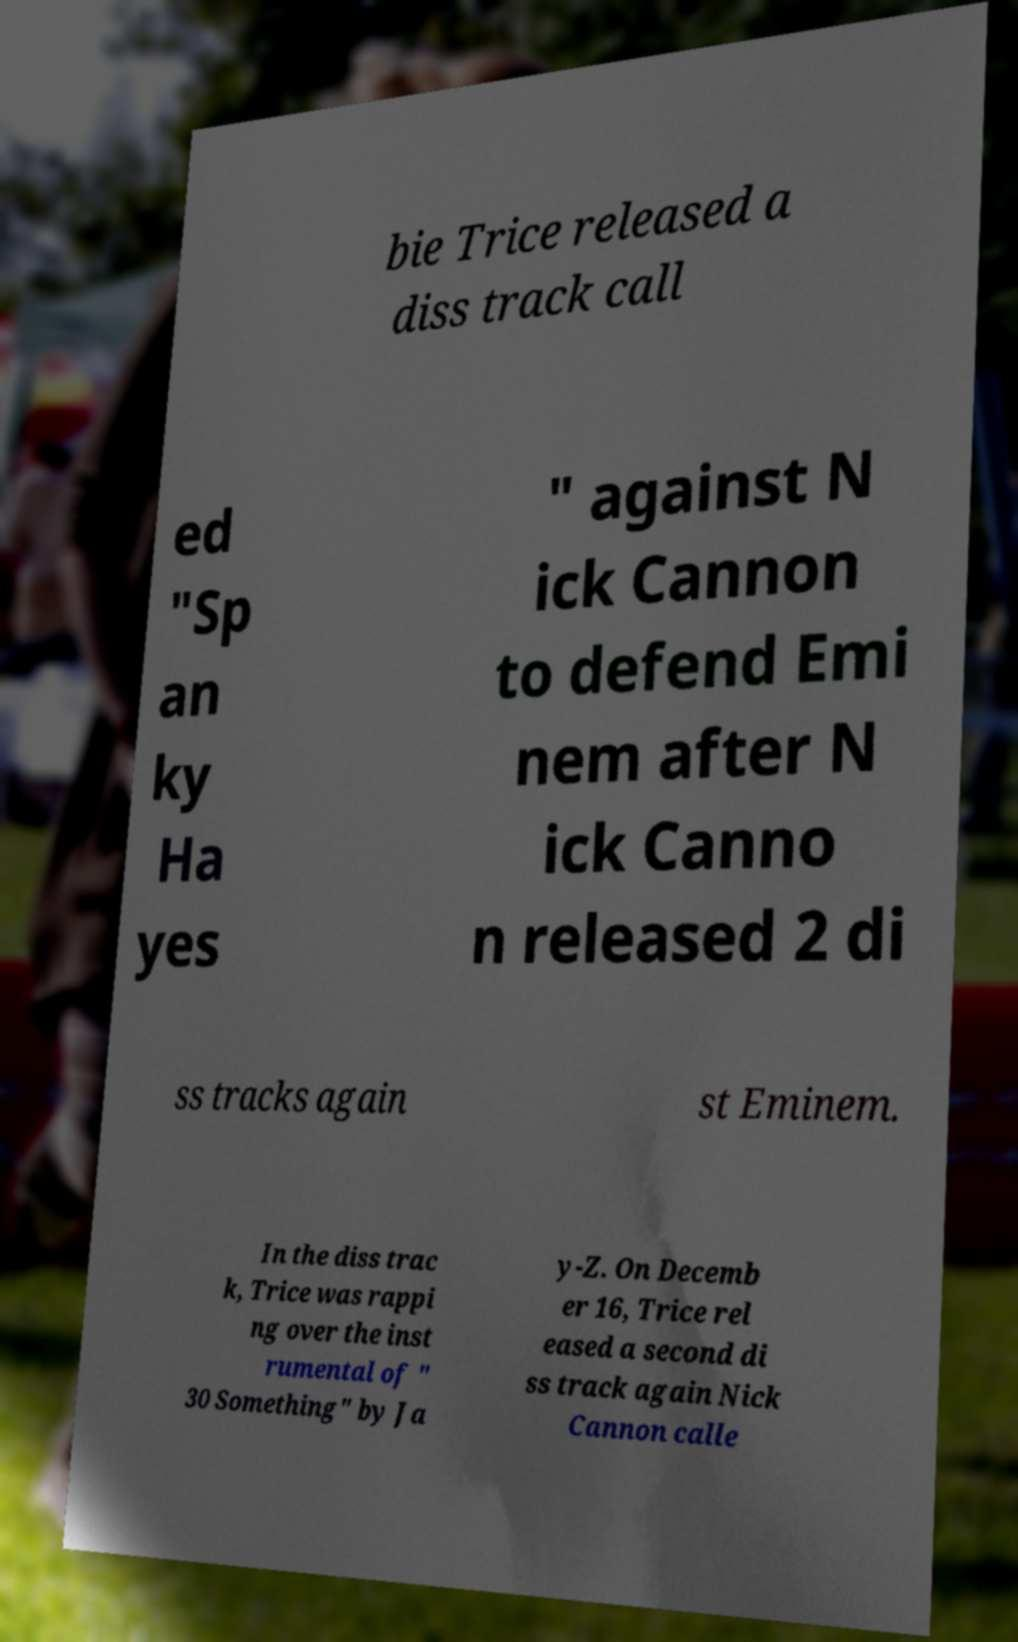There's text embedded in this image that I need extracted. Can you transcribe it verbatim? bie Trice released a diss track call ed "Sp an ky Ha yes " against N ick Cannon to defend Emi nem after N ick Canno n released 2 di ss tracks again st Eminem. In the diss trac k, Trice was rappi ng over the inst rumental of " 30 Something" by Ja y-Z. On Decemb er 16, Trice rel eased a second di ss track again Nick Cannon calle 